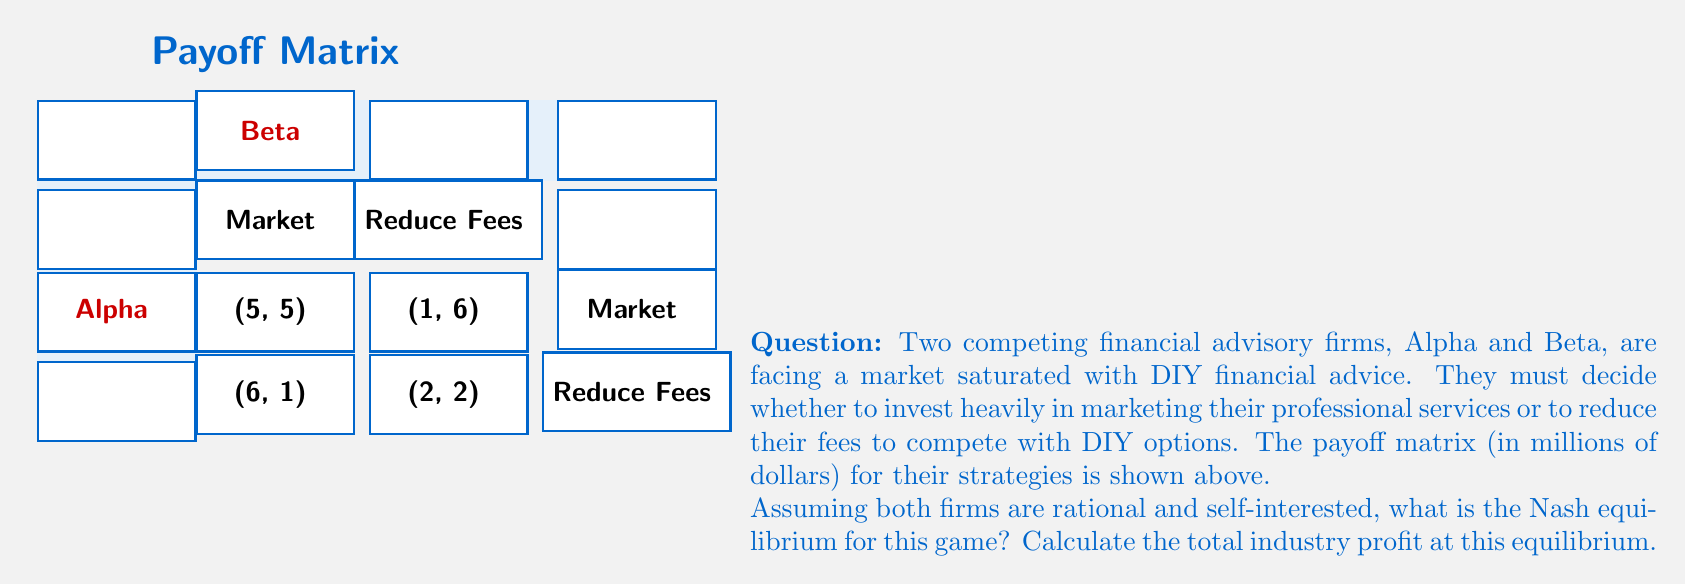Can you solve this math problem? To solve this problem, we need to follow these steps:

1. Identify the dominant strategy for each firm:

For Alpha:
- If Beta markets: $5 > 1$, so Alpha prefers to market
- If Beta reduces fees: $6 > 2$, so Alpha prefers to market

For Beta:
- If Alpha markets: $5 > 1$, so Beta prefers to market
- If Alpha reduces fees: $6 > 2$, so Beta prefers to market

Both firms have a dominant strategy to market their services.

2. Determine the Nash equilibrium:

The Nash equilibrium occurs where both firms choose their dominant strategy, which is (Market, Market).

3. Calculate the total industry profit at this equilibrium:

At (Market, Market), Alpha's profit is $5 million and Beta's profit is $5 million.

Total industry profit = Alpha's profit + Beta's profit
$$5 + 5 = 10$$ million

Therefore, the Nash equilibrium is (Market, Market), and the total industry profit at this equilibrium is $10 million.

This outcome aligns with the persona of a financial adviser who disapproves of DIY financial advice, as both firms choose to market their professional services rather than competing on price with DIY options.
Answer: Nash equilibrium: (Market, Market); Total industry profit: $10 million 